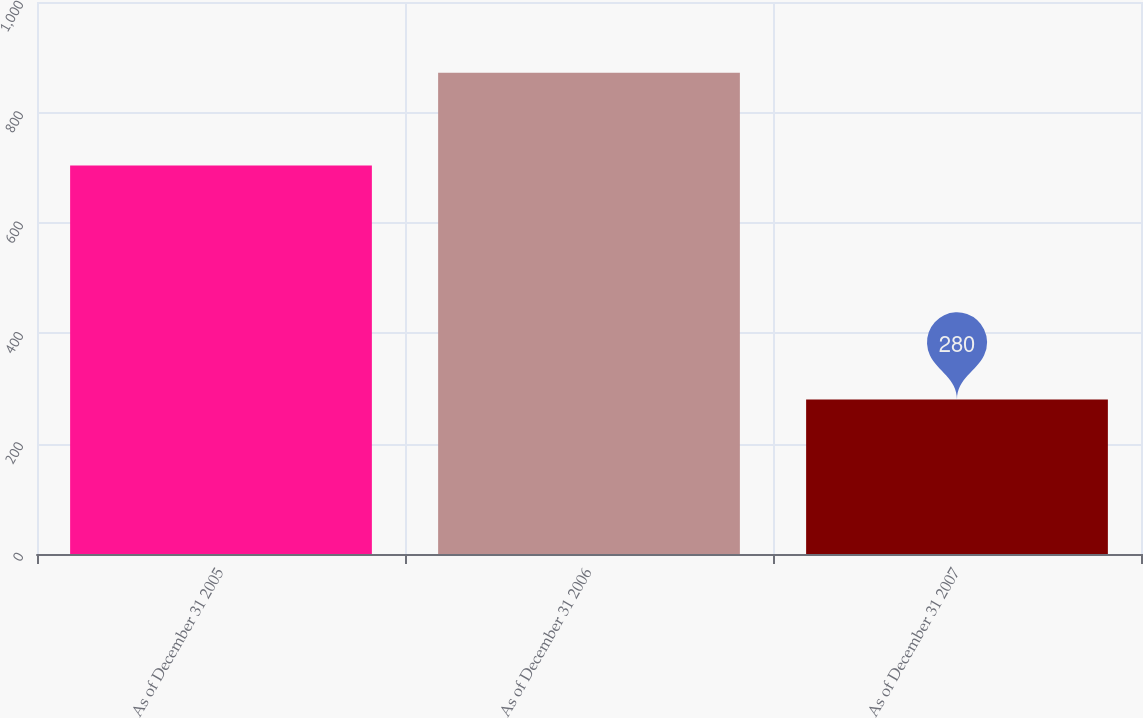<chart> <loc_0><loc_0><loc_500><loc_500><bar_chart><fcel>As of December 31 2005<fcel>As of December 31 2006<fcel>As of December 31 2007<nl><fcel>704<fcel>872<fcel>280<nl></chart> 